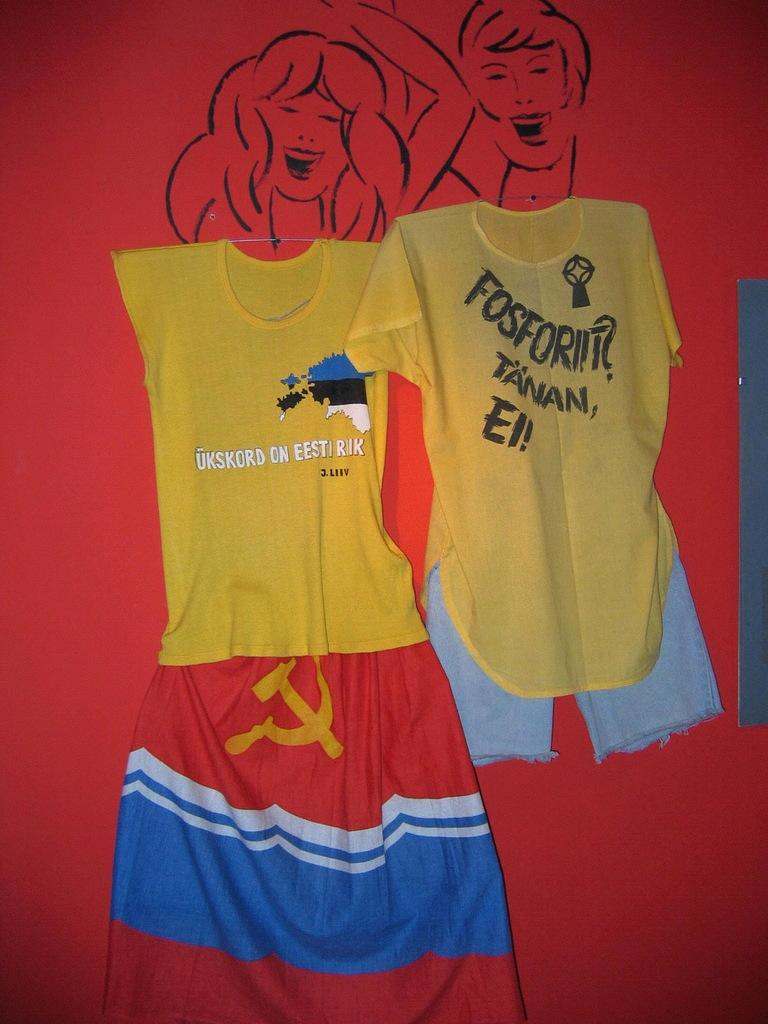What is on the wall in the image? There is a drawing on the wall in the image. What does the drawing depict? The drawing depicts two persons. What type of clothing can be seen in the image? There are t-shirts and shorts visible in the image. What is written on the t-shirts? There is text visible on the t-shirts. What type of lumber is being used to support the wall in the image? There is no mention of lumber or any support structure for the wall in the image. How many boots are visible in the image? There are no boots present in the image. 